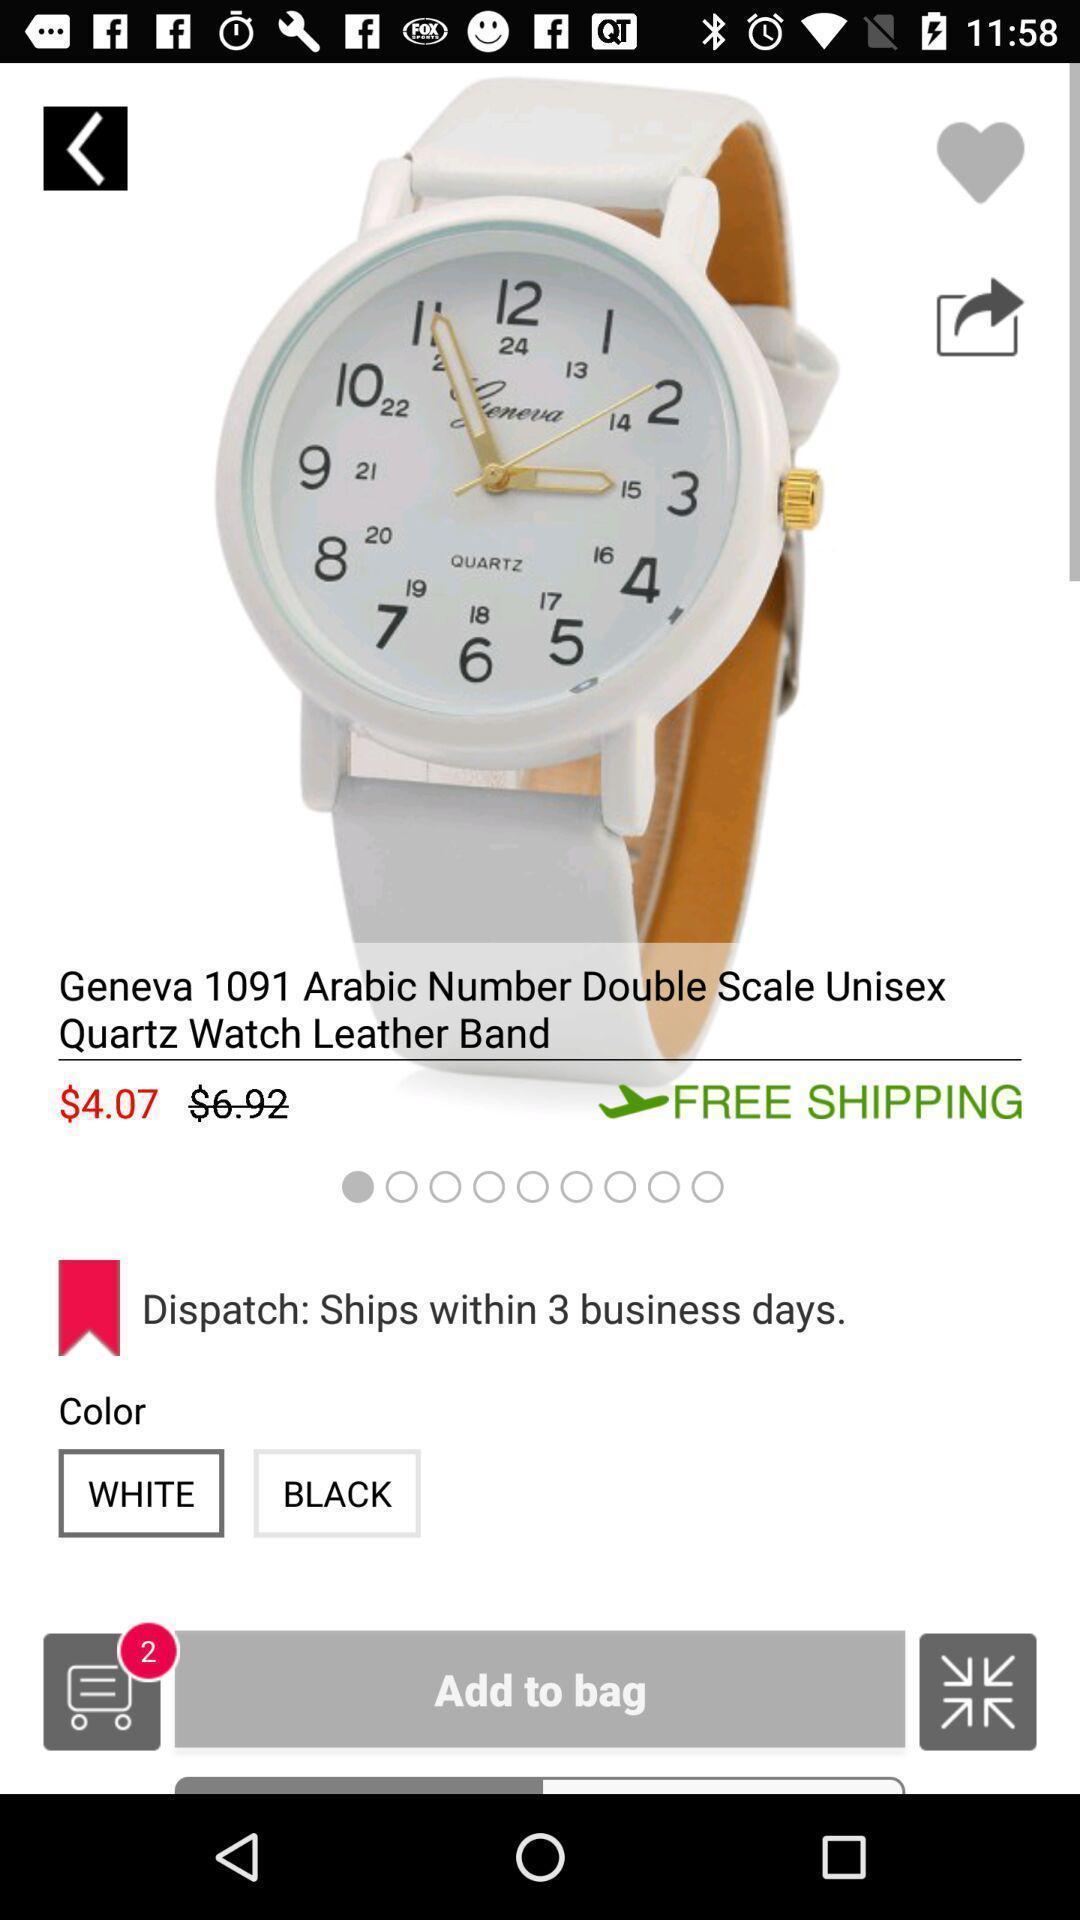Explain the elements present in this screenshot. Page displaying watch details on shopping app. 